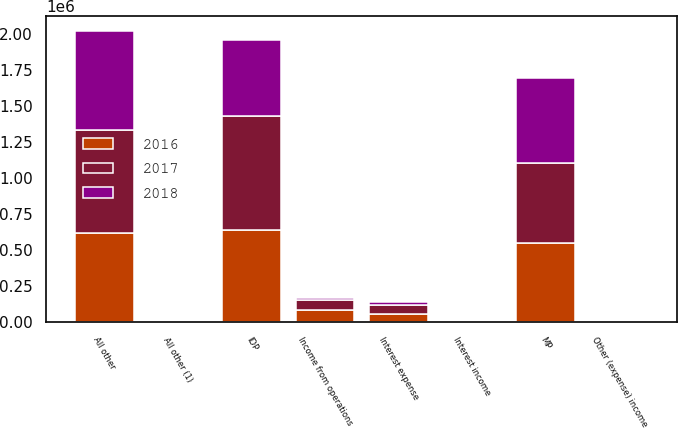Convert chart. <chart><loc_0><loc_0><loc_500><loc_500><stacked_bar_chart><ecel><fcel>IDP<fcel>All other (1)<fcel>MP<fcel>All other<fcel>Income from operations<fcel>Interest expense<fcel>Interest income<fcel>Other (expense) income<nl><fcel>2017<fcel>788495<fcel>3880<fcel>549574<fcel>715011<fcel>70282<fcel>59548<fcel>7017<fcel>606<nl><fcel>2016<fcel>644653<fcel>3880<fcel>554001<fcel>618481<fcel>88059<fcel>58879<fcel>1212<fcel>3087<nl><fcel>2018<fcel>523512<fcel>3880<fcel>591751<fcel>688153<fcel>11968<fcel>23316<fcel>2068<fcel>6418<nl></chart> 